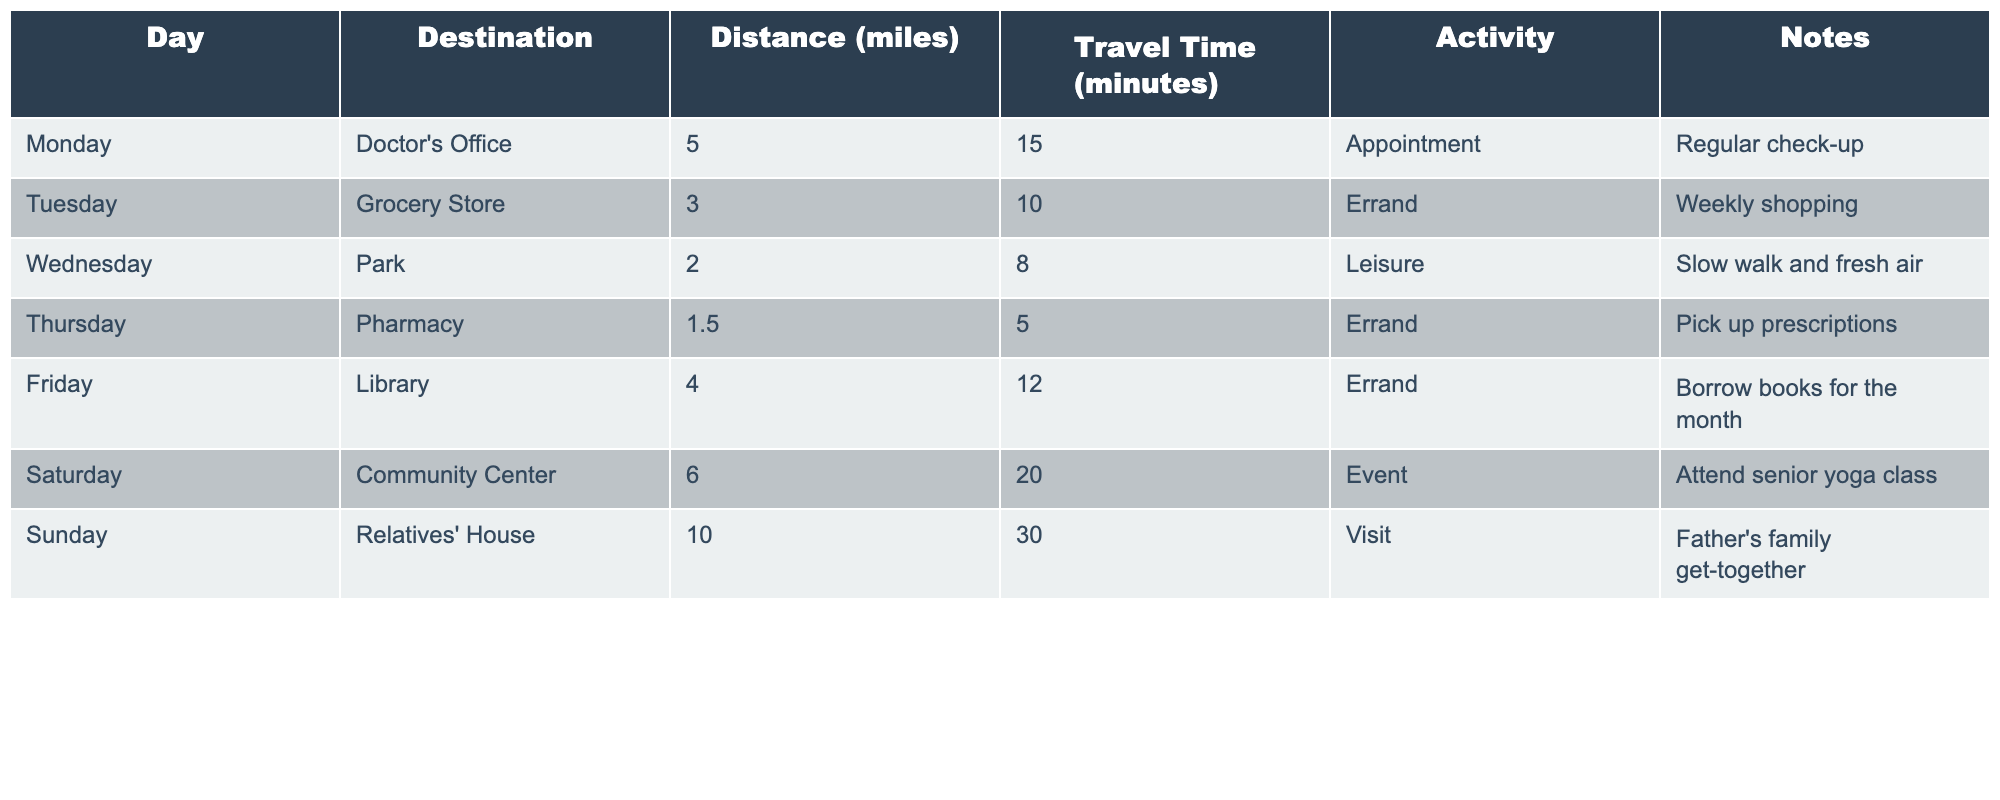What is the total distance traveled in a week? By adding the distances for each day: 5 + 3 + 2 + 1.5 + 4 + 6 + 10 = 32.5 miles
Answer: 32.5 miles On which day did we spend the most travel time? Comparing the travel times for each day reveals that Sunday has the longest travel time at 30 minutes.
Answer: Sunday What is the average travel time across all outings? The total travel time is 15 + 10 + 8 + 5 + 12 + 20 + 30 = 110 minutes. To find the average, we divide by the number of outings (7): 110 / 7 ≈ 15.71 minutes.
Answer: Approximately 15.71 minutes Did we visit more places for errands or leisure activities? There are 3 errands (Grocery Store, Pharmacy, Library) and 1 leisure activity (Park), indicating more errand visits.
Answer: Yes, more errands What is the distance difference between the longest and shortest trip? The longest trip is to Relatives' House at 10 miles, and the shortest is to Pharmacy at 1.5 miles. The difference is 10 - 1.5 = 8.5 miles.
Answer: 8.5 miles How many activities are considered appointments? Only one activity is listed as an appointment, which is on Monday at the Doctor's Office.
Answer: 1 What is the total time spent on errands compared to leisure activities? The total time for errands is 10 (Grocery Store) + 5 (Pharmacy) + 12 (Library) = 27 minutes. Leisure activity time is 8 minutes (Park). Therefore, errands take longer.
Answer: Errands take longer 